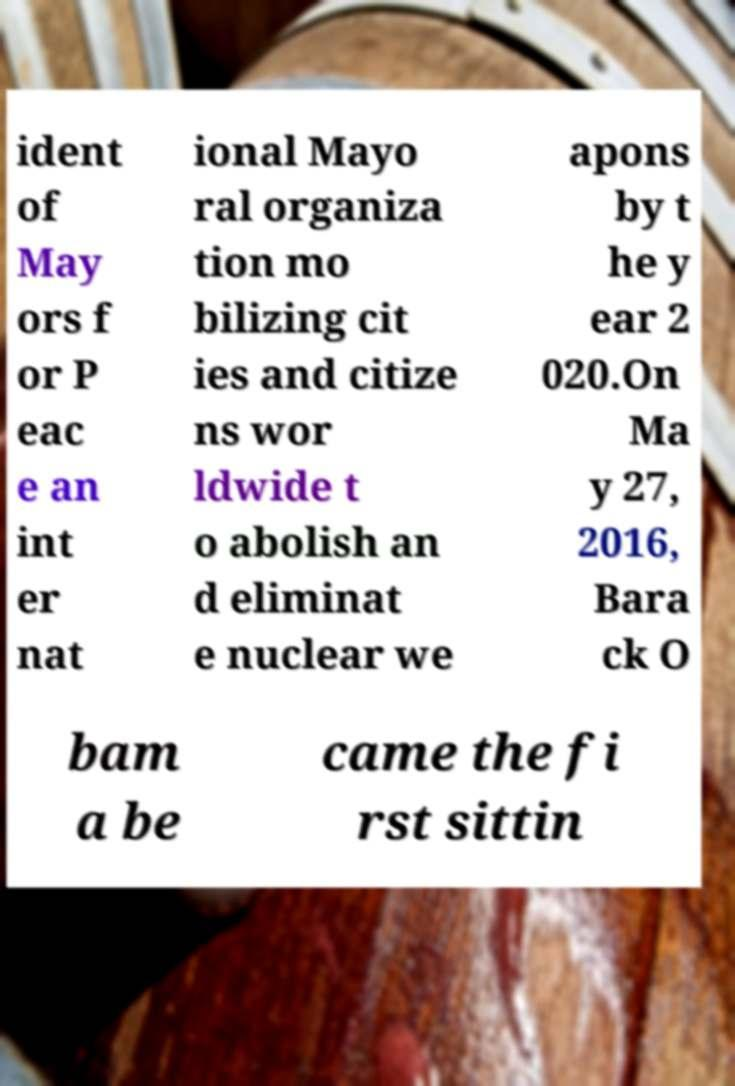Please identify and transcribe the text found in this image. ident of May ors f or P eac e an int er nat ional Mayo ral organiza tion mo bilizing cit ies and citize ns wor ldwide t o abolish an d eliminat e nuclear we apons by t he y ear 2 020.On Ma y 27, 2016, Bara ck O bam a be came the fi rst sittin 